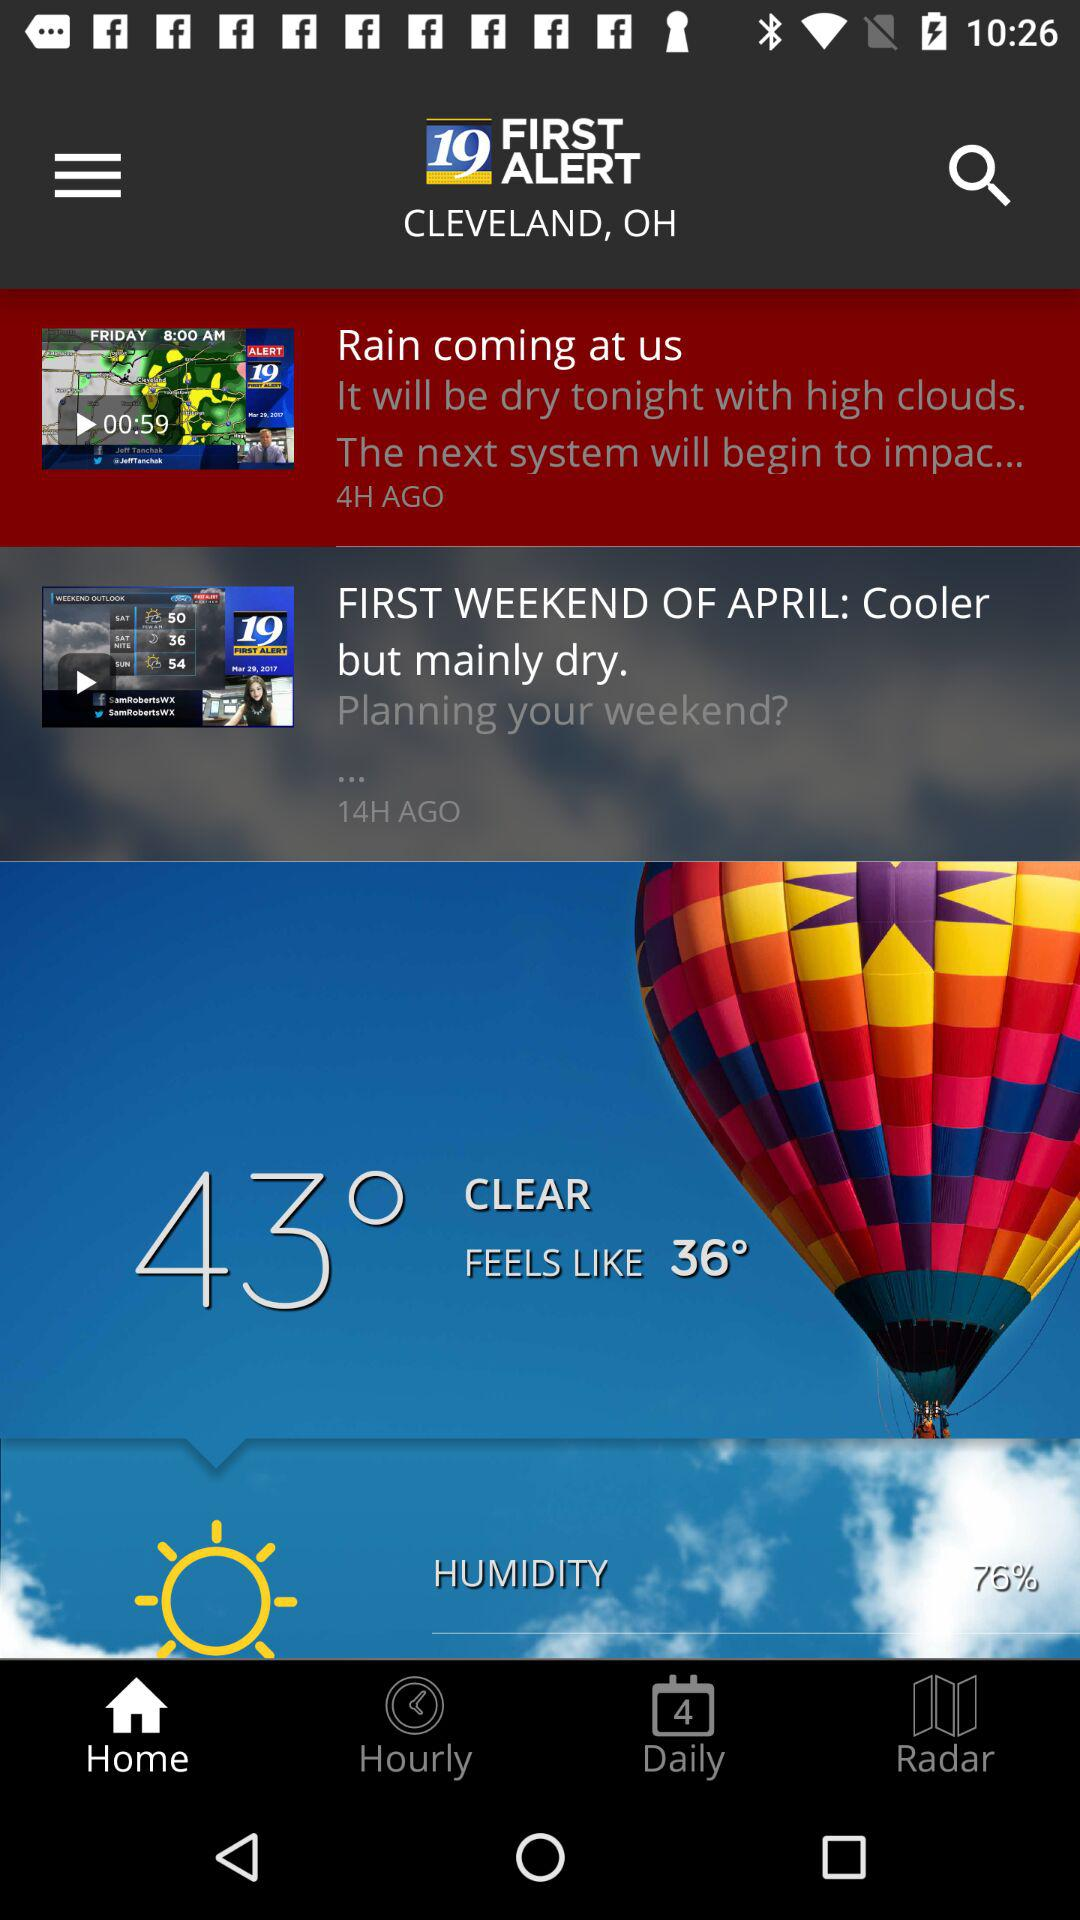How much higher is the temperature than the feels like temperature?
Answer the question using a single word or phrase. 7° 